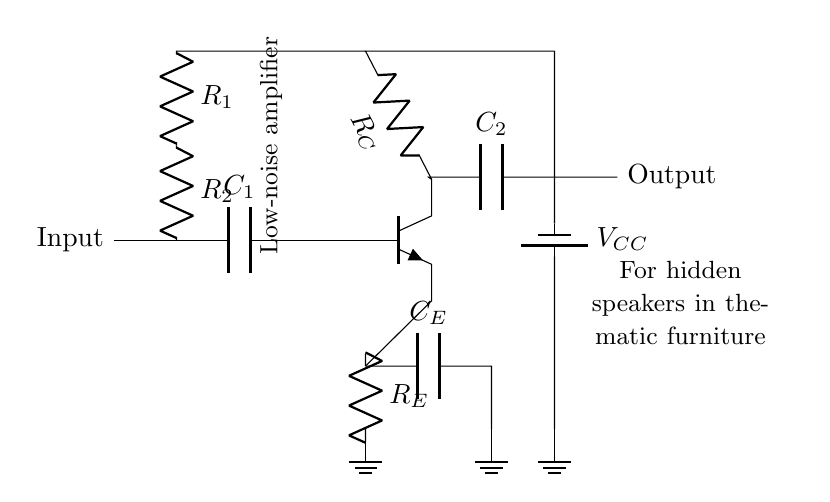What component is used for decoupling? The decoupling capacitor is indicated in the circuit as **C_E**, and it is positioned between the emitter of the transistor and ground. Its function is to stabilize the power supply by minimizing voltage fluctuations.
Answer: C_E What is the type of the transistor used in this circuit? The circuit diagram shows an npn transistor, which is indicated by the symbol drawn with an arrow pointing out from the emitter. This configuration is common in low-noise amplifier designs to enhance the input signal.
Answer: npn What are the values of the resistors used in the amplifier? The diagram does not provide specific numerical values for resistors **R_E**, **R_C**, **R_1**, and **R_2**, only symbols representing them. Typically, these resistors can vary based on the desired gain and impedance matching of the amplifier circuit.
Answer: Not specified What is the purpose of **C_1** in the circuit? Capacitor **C_1** is connected at the input and functions to couple the input AC signal to the amplifier while blocking any DC components. This allows only the alternating signal to pass through for amplification.
Answer: Coupling What type of amplifier is represented by this circuit? The circuit represents a low-noise amplifier, which is designed to amplify signals while adding minimal noise to the output. This is essential in obtaining clear sound from hidden speakers within thematic furniture without unwanted interference.
Answer: Low-noise amplifier What is represented by **V_CC** in this circuit? **V_CC** refers to the power supply voltage for the circuit. It powers the transistor and other components, ensuring they operate correctly and the circuit functions as intended. The value is not specified in the diagram but is necessary for operation.
Answer: Power supply 